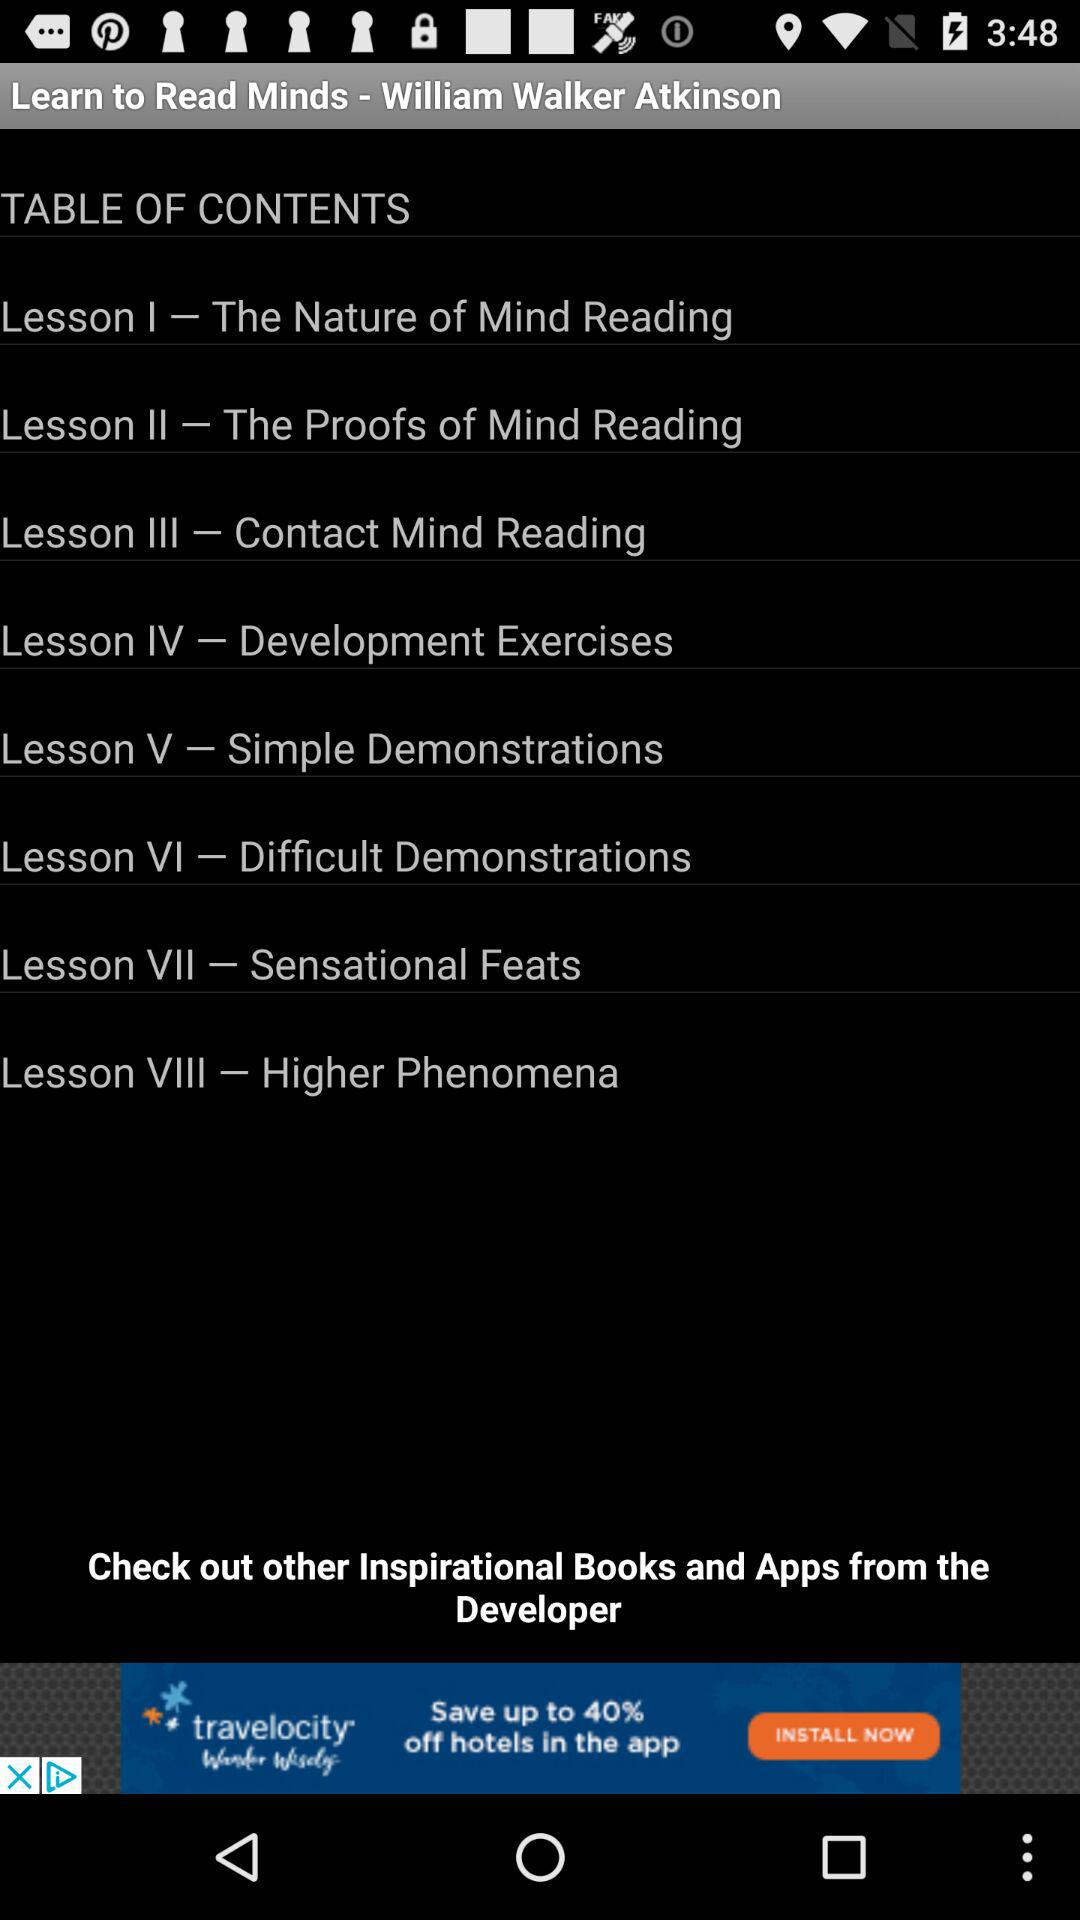What is the name of Lesson VII? The name of the Lesson VII is "Sensational Feats". 